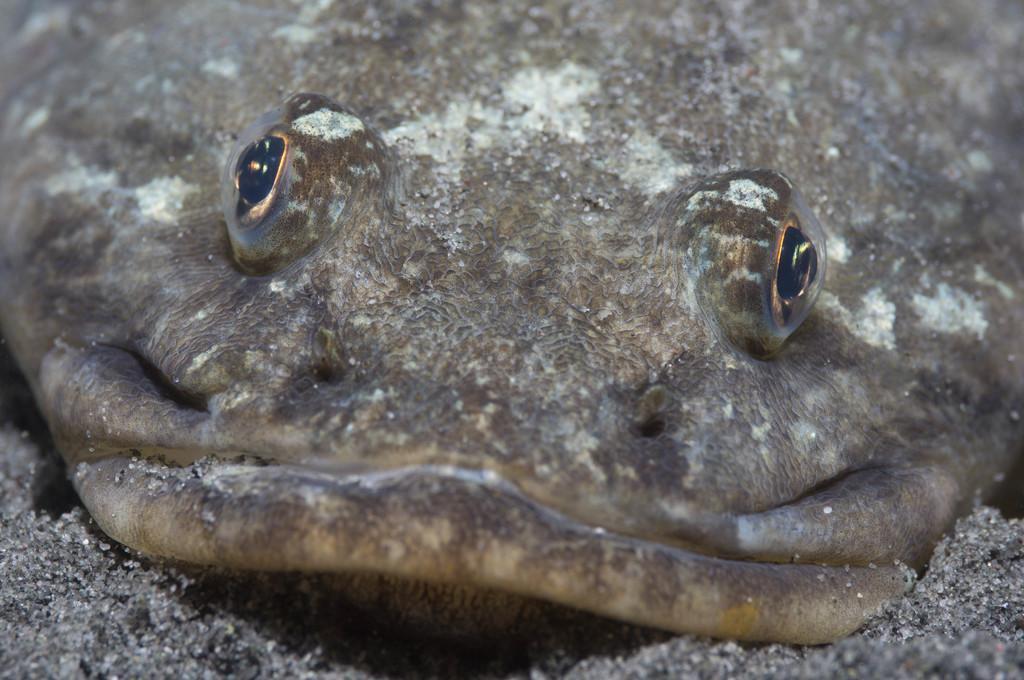In one or two sentences, can you explain what this image depicts? In the image in the center, we can see one reptile, which is brown in color. 